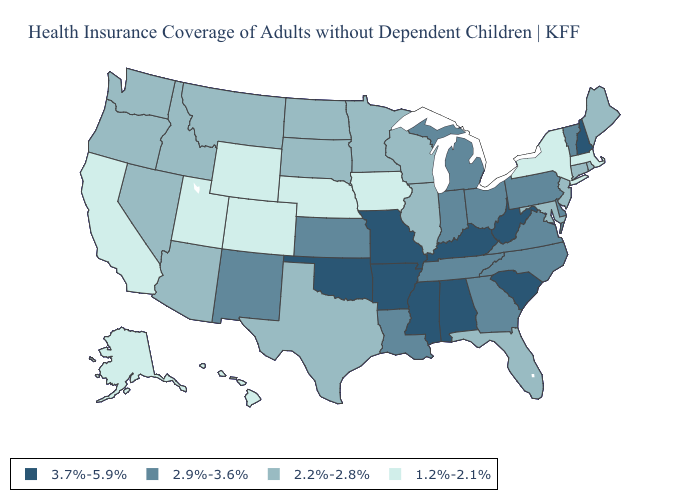Does Ohio have the highest value in the MidWest?
Answer briefly. No. Name the states that have a value in the range 1.2%-2.1%?
Give a very brief answer. Alaska, California, Colorado, Hawaii, Iowa, Massachusetts, Nebraska, New York, Utah, Wyoming. What is the value of South Carolina?
Answer briefly. 3.7%-5.9%. Among the states that border Arkansas , does Louisiana have the highest value?
Give a very brief answer. No. Does Connecticut have the lowest value in the Northeast?
Keep it brief. No. Is the legend a continuous bar?
Answer briefly. No. Does the map have missing data?
Be succinct. No. Which states have the lowest value in the USA?
Give a very brief answer. Alaska, California, Colorado, Hawaii, Iowa, Massachusetts, Nebraska, New York, Utah, Wyoming. Does Vermont have a higher value than South Dakota?
Short answer required. Yes. Name the states that have a value in the range 2.9%-3.6%?
Short answer required. Delaware, Georgia, Indiana, Kansas, Louisiana, Michigan, New Mexico, North Carolina, Ohio, Pennsylvania, Tennessee, Vermont, Virginia. What is the value of Maine?
Give a very brief answer. 2.2%-2.8%. Which states have the lowest value in the West?
Be succinct. Alaska, California, Colorado, Hawaii, Utah, Wyoming. How many symbols are there in the legend?
Short answer required. 4. Does the first symbol in the legend represent the smallest category?
Quick response, please. No. What is the highest value in the Northeast ?
Concise answer only. 3.7%-5.9%. 